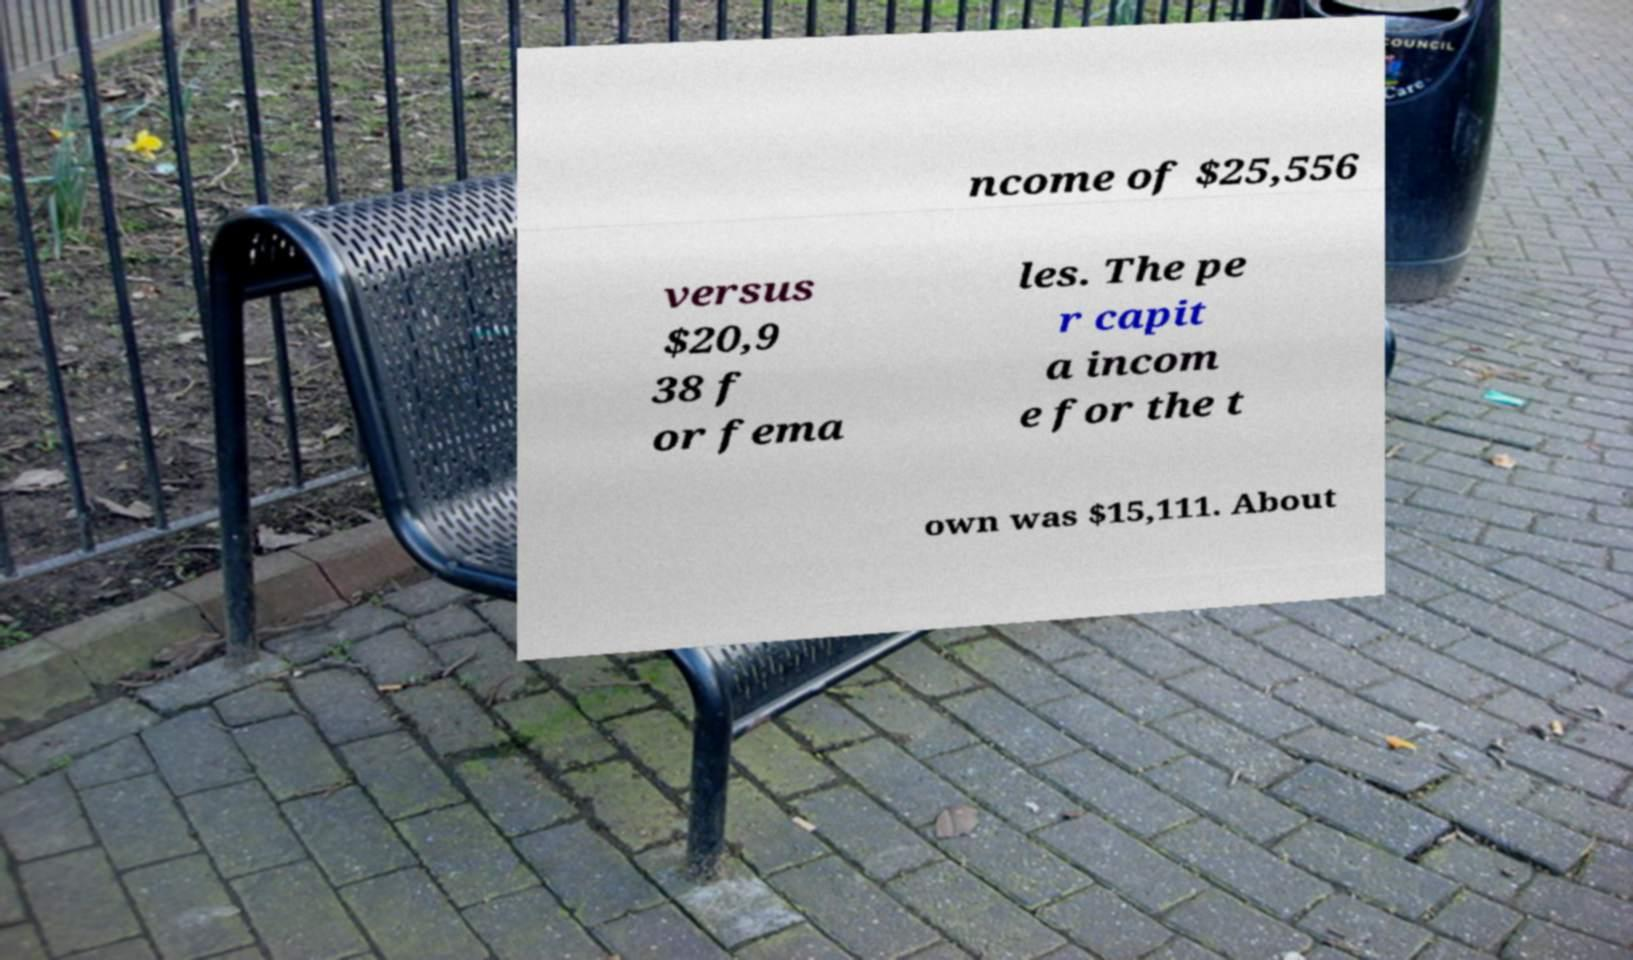I need the written content from this picture converted into text. Can you do that? ncome of $25,556 versus $20,9 38 f or fema les. The pe r capit a incom e for the t own was $15,111. About 